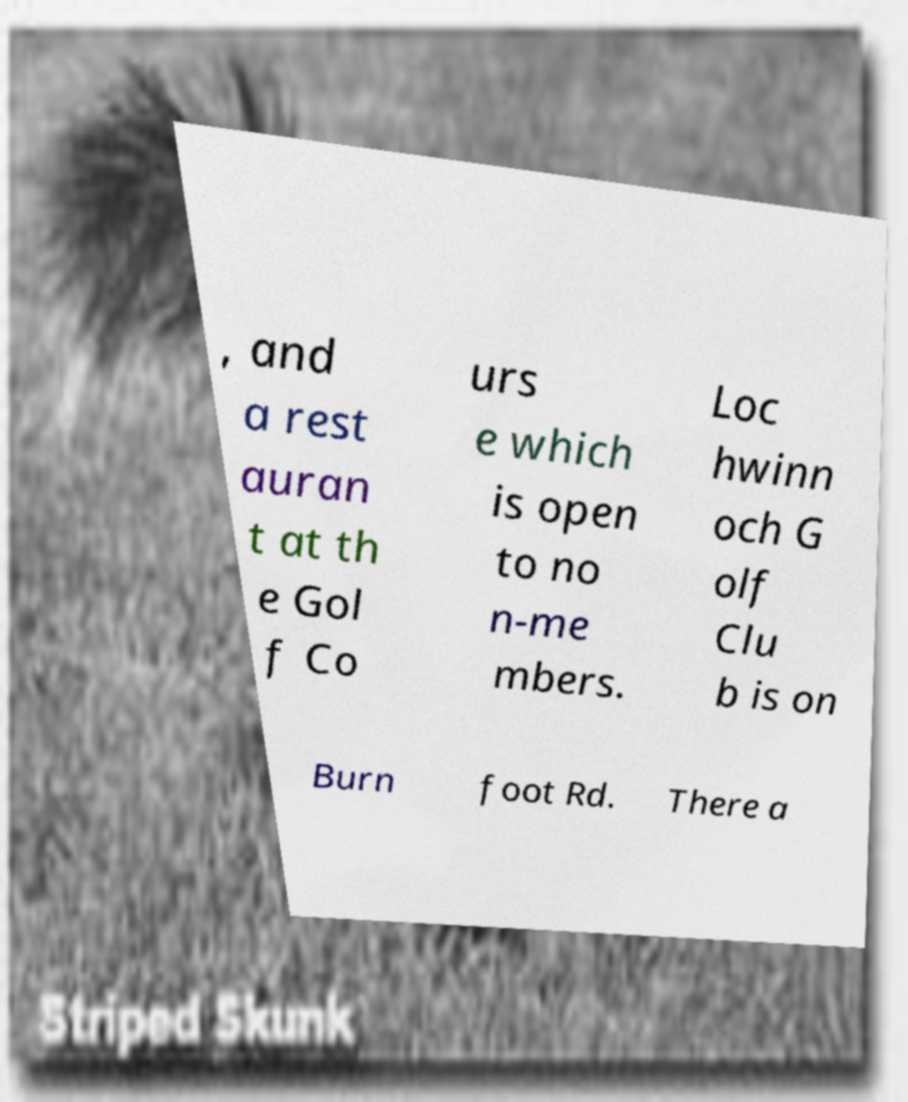Can you read and provide the text displayed in the image?This photo seems to have some interesting text. Can you extract and type it out for me? , and a rest auran t at th e Gol f Co urs e which is open to no n-me mbers. Loc hwinn och G olf Clu b is on Burn foot Rd. There a 